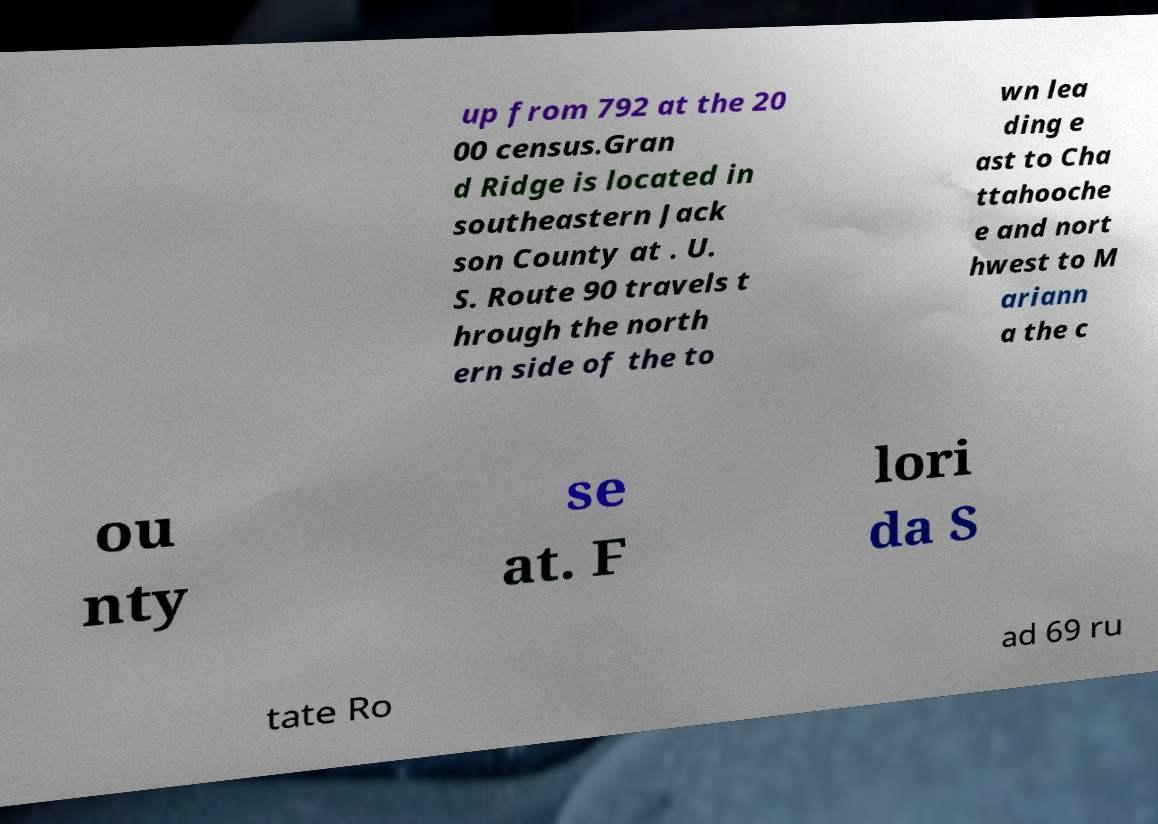For documentation purposes, I need the text within this image transcribed. Could you provide that? up from 792 at the 20 00 census.Gran d Ridge is located in southeastern Jack son County at . U. S. Route 90 travels t hrough the north ern side of the to wn lea ding e ast to Cha ttahooche e and nort hwest to M ariann a the c ou nty se at. F lori da S tate Ro ad 69 ru 